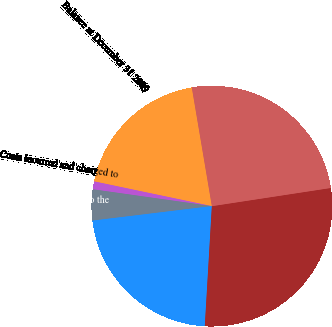<chart> <loc_0><loc_0><loc_500><loc_500><pie_chart><fcel>Balance at December 31 2009<fcel>Costs incurred and charged to<fcel>Adjustments related to the<fcel>Costs paid or settled<fcel>Liability Balance at December<fcel>Cumulative restructuring costs<nl><fcel>19.04%<fcel>1.06%<fcel>4.16%<fcel>22.14%<fcel>28.35%<fcel>25.25%<nl></chart> 